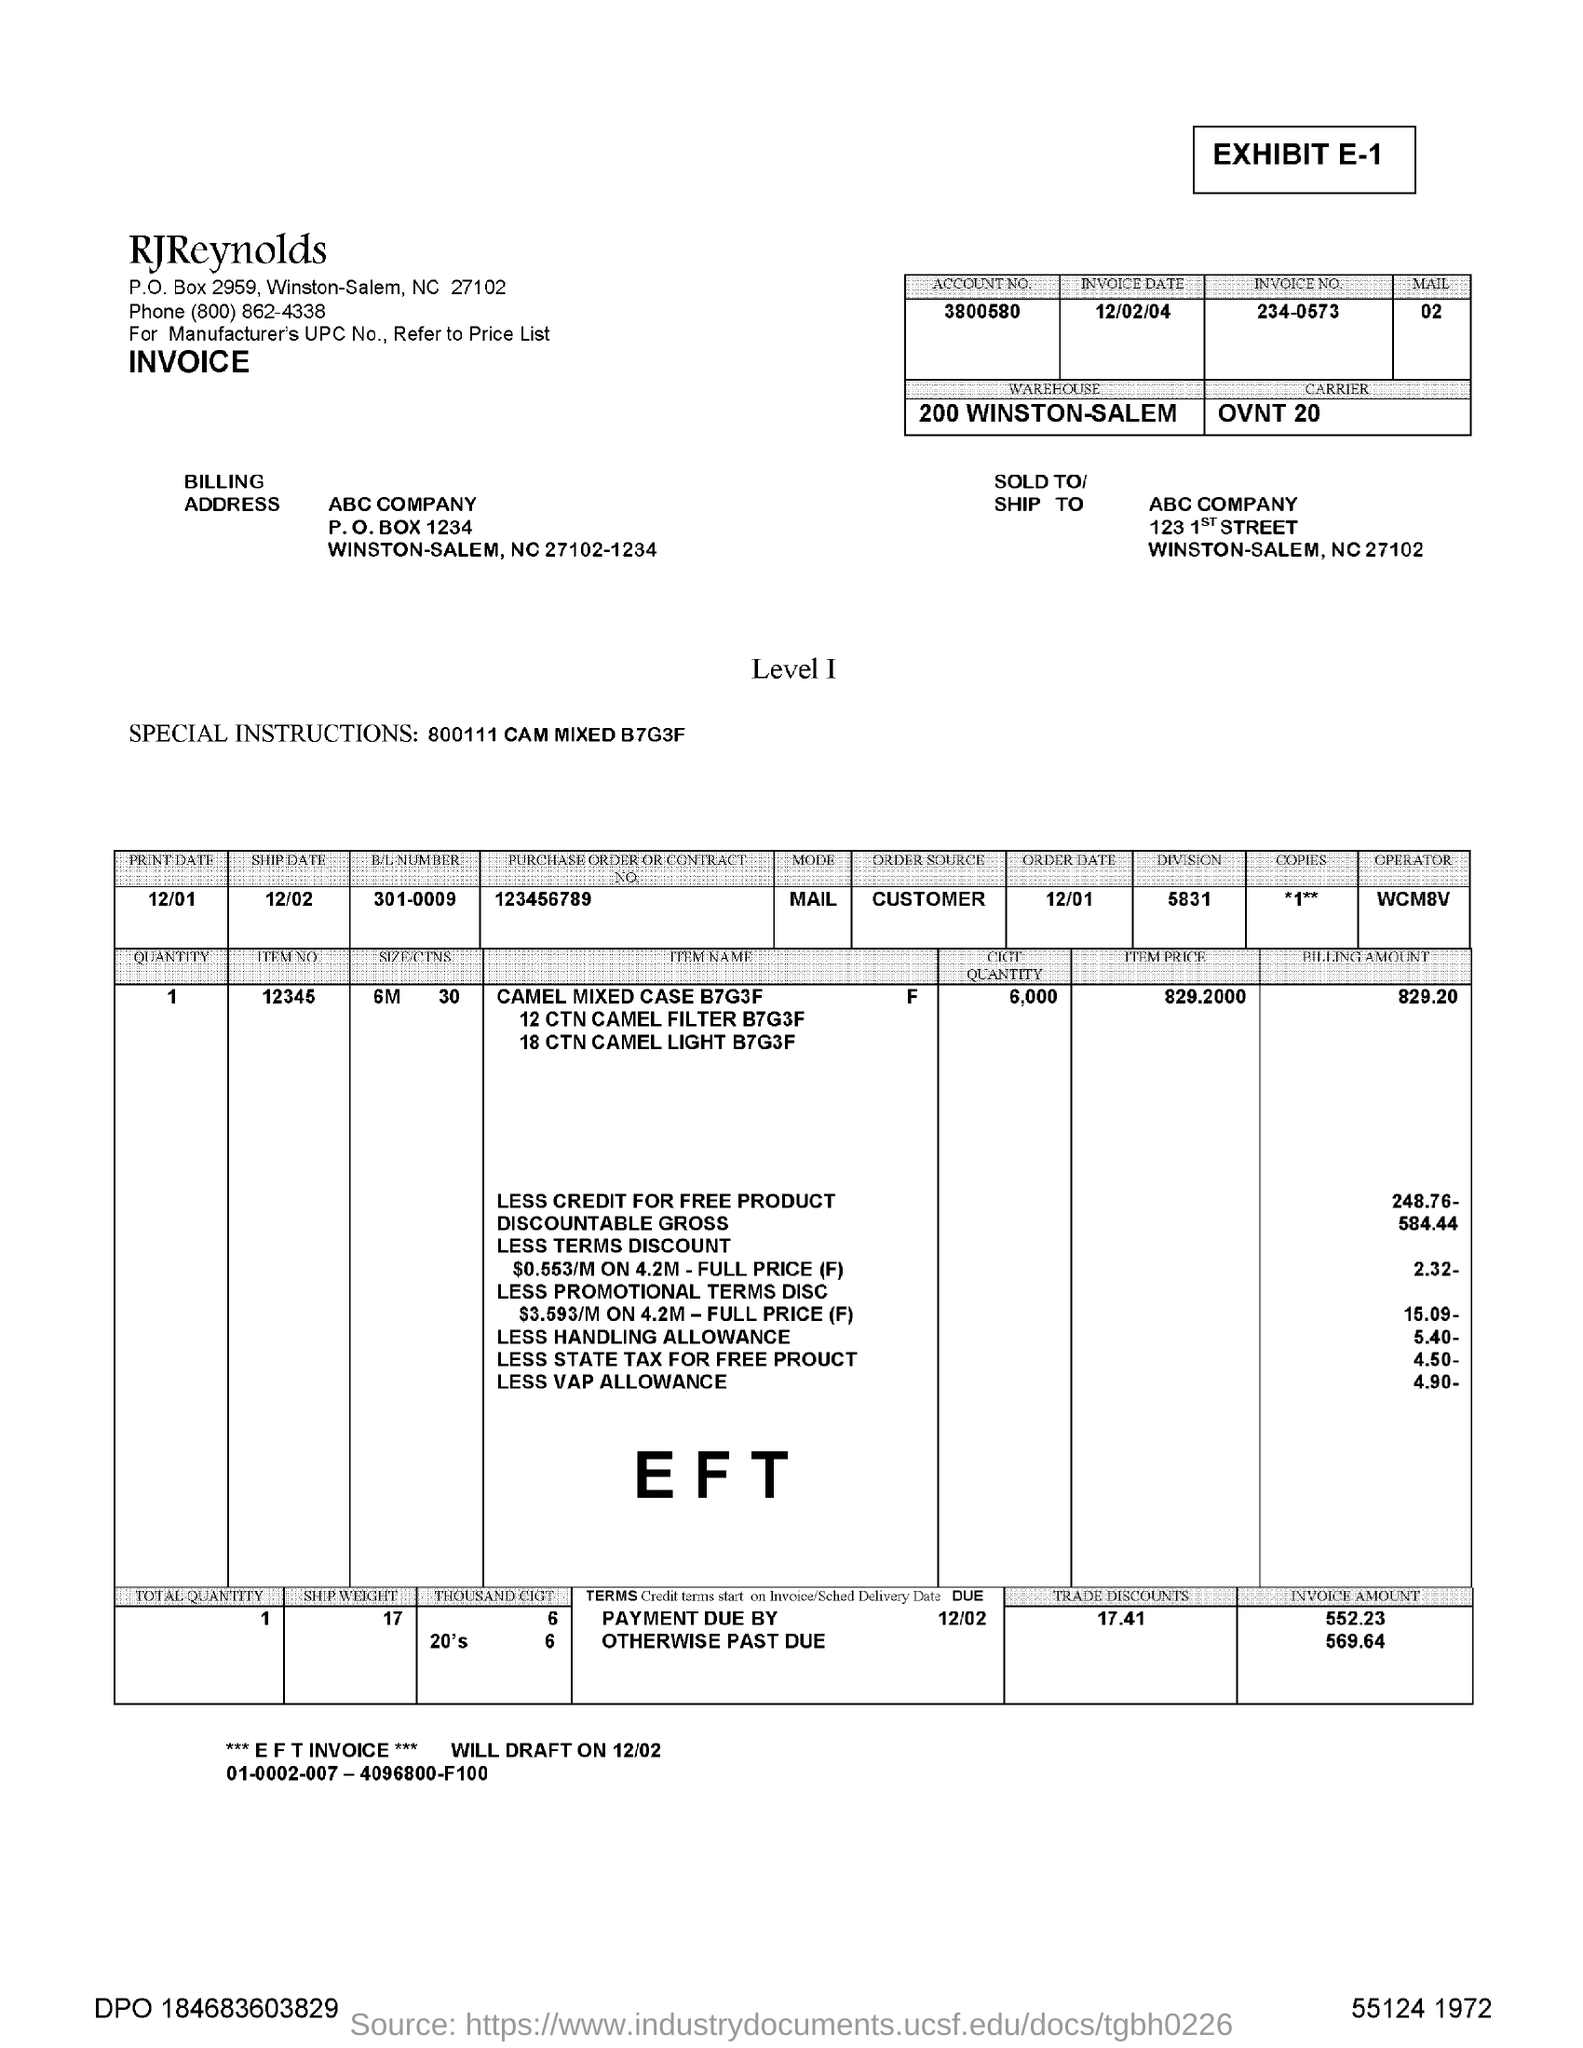What is the account number given?
Provide a short and direct response. 3800580. What is the invoice date?
Your response must be concise. 12/02/04. What is the invoice no.?
Offer a very short reply. 234-0573. What special instructions are given?
Provide a succinct answer. 800111 CAM MIXED B7G3F. What is the B/L NUMBER?
Provide a short and direct response. 301-0009. What is the order source?
Provide a succinct answer. CUSTOMER. When is the ship date?
Provide a succinct answer. 12/02. 